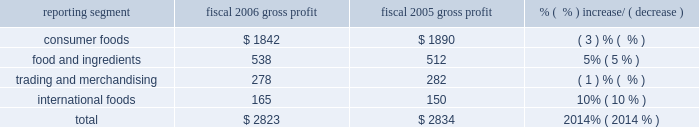Consumer foods net sales decreased $ 94 million for the year to $ 6.5 billion .
Sales volume declined by 1% ( 1 % ) in fiscal 2006 , principally due to declines in certain shelf stable brands .
Sales of the company 2019s top thirty brands , which represented approximately 83% ( 83 % ) of total segment sales during fiscal 2006 , were flat as a group , as sales of some of the company 2019s most significant brands , including chef boyardee ae , marie callender 2019s ae , orville redenbacher 2019s ae , slim jim ae , hebrew national ae , kid cuisine ae , reddi-wip ae , vancamp ae , libby 2019s ae , lachoy ae , the max ae , manwich ae , david 2019s ae , ro*tel ae , angela mia ae , and mama rosa ae grew in fiscal 2006 , but were largely offset by sales declines for the year for hunt 2019s ae , wesson ae , act ii ae , snack pack ae , swiss miss ae , pam ae , egg beaters ae , blue bonnet ae , parkay ae , and rosarita ae .
Food and ingredients net sales increased $ 203 million to $ 3.2 billion , primarily reflecting price increases driven by higher input costs for potato , wheat milling , and dehydrated vegetable operations .
Net sales were also impacted , to a lesser degree , by a 4% ( 4 % ) increase in potato products volume compared to the prior year .
Trading and merchandising net sales decreased $ 38 million to $ 1.2 billion .
The decrease resulted principally from lower grain and edible bean merchandising volume resulting from the divestment or closure of various locations .
International foods net sales increased $ 27 million to $ 603 million .
The strengthening of foreign currencies relative to the u.s .
Dollar accounted for $ 24 million of the increase .
Overall volume growth was modest as the 10% ( 10 % ) volume growth from the top six international brands ( orville redenbacher 2019s ae , act ii ae , snack pack ae , chef boyardee ae , hunt 2019s ae , and pam ae ) , which account for 55% ( 55 % ) of total segment sales , was offset by sales declines related to the discontinuance of a number of low margin products .
Gross profit ( net sales less cost of goods sold ) ( $ in millions ) reporting segment fiscal 2006 gross profit fiscal 2005 gross profit % (  % ) increase/ ( decrease ) .
The company 2019s gross profit for fiscal 2006 was $ 2.8 billion , a decrease of $ 11 million from the prior year , as improvements in the foods and ingredients and international foods segments were more than offset by declines in the consumer foods and trading and merchandising segments .
Gross profit includes $ 20 million of costs associated with the company 2019s restructuring plans in fiscal 2006 , and $ 17 million of costs incurred to implement the company 2019s operational efficiency initiatives in fiscal 2005 .
Consumer foods gross profit for fiscal 2006 was $ 1.8 billion , a decrease of $ 48 million from fiscal 2005 , driven principally by a 2% ( 2 % ) decline in sales volumes .
Fiscal 2006 gross profit includes $ 20 million of costs related to the company 2019s restructuring plan , and fiscal 2005 gross profit includes $ 16 million of costs related to implementing the company 2019s operational efficiency initiatives .
Gross profit was negatively impacted by increased costs of fuel and energy , transportation and warehousing , steel , and other packaging materials in both fiscal 2006 and 2005 .
Food and ingredients gross profit for fiscal 2006 was $ 538 million , an increase of $ 26 million over the prior year .
The gross profit improvement was driven almost entirely by the vegetable processing and dehydration businesses ( including potatoes , garlic , onions , and chili peppers ) as a result of higher volume ( both domestic and export ) , increased value-added sales mix and pricing improvements partially offset by higher raw product and conversion costs. .
What percentage of total gross profit was due to food and ingredients in fiscal 2005? 
Computations: (512 / 2834)
Answer: 0.18066. 